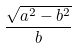<formula> <loc_0><loc_0><loc_500><loc_500>\frac { \sqrt { a ^ { 2 } - b ^ { 2 } } } { b }</formula> 